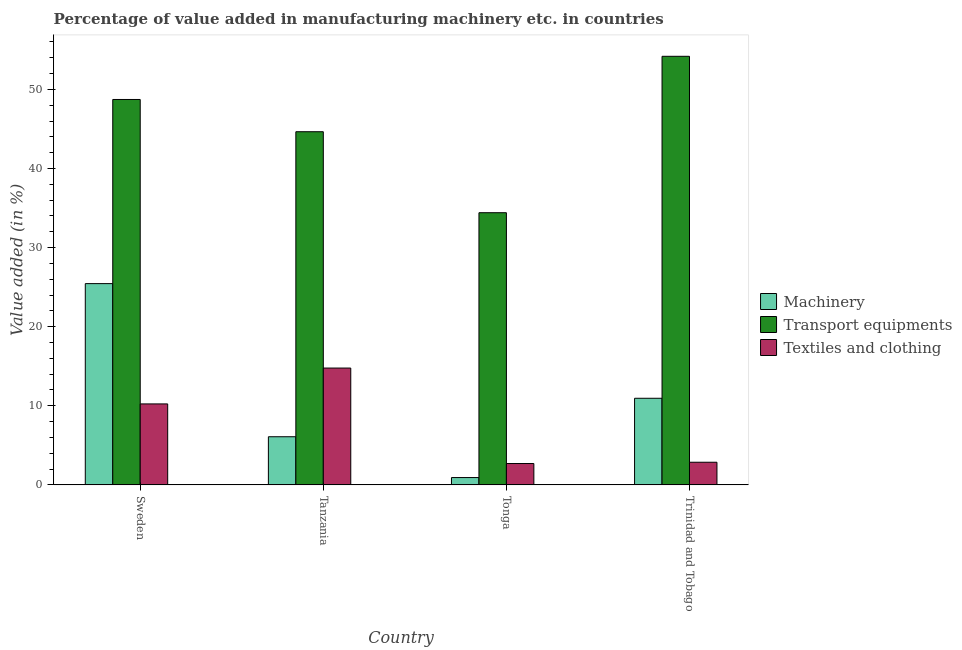How many groups of bars are there?
Keep it short and to the point. 4. Are the number of bars on each tick of the X-axis equal?
Provide a succinct answer. Yes. How many bars are there on the 1st tick from the right?
Make the answer very short. 3. What is the label of the 2nd group of bars from the left?
Ensure brevity in your answer.  Tanzania. In how many cases, is the number of bars for a given country not equal to the number of legend labels?
Keep it short and to the point. 0. What is the value added in manufacturing textile and clothing in Sweden?
Your response must be concise. 10.24. Across all countries, what is the maximum value added in manufacturing transport equipments?
Offer a terse response. 54.19. Across all countries, what is the minimum value added in manufacturing transport equipments?
Keep it short and to the point. 34.41. In which country was the value added in manufacturing transport equipments maximum?
Provide a short and direct response. Trinidad and Tobago. In which country was the value added in manufacturing textile and clothing minimum?
Ensure brevity in your answer.  Tonga. What is the total value added in manufacturing textile and clothing in the graph?
Offer a terse response. 30.58. What is the difference between the value added in manufacturing transport equipments in Sweden and that in Tanzania?
Keep it short and to the point. 4.08. What is the difference between the value added in manufacturing textile and clothing in Trinidad and Tobago and the value added in manufacturing machinery in Tanzania?
Keep it short and to the point. -3.22. What is the average value added in manufacturing transport equipments per country?
Give a very brief answer. 45.5. What is the difference between the value added in manufacturing textile and clothing and value added in manufacturing transport equipments in Trinidad and Tobago?
Offer a terse response. -51.32. In how many countries, is the value added in manufacturing machinery greater than 26 %?
Offer a very short reply. 0. What is the ratio of the value added in manufacturing textile and clothing in Sweden to that in Trinidad and Tobago?
Offer a terse response. 3.57. Is the value added in manufacturing transport equipments in Sweden less than that in Tonga?
Offer a terse response. No. What is the difference between the highest and the second highest value added in manufacturing machinery?
Give a very brief answer. 14.5. What is the difference between the highest and the lowest value added in manufacturing transport equipments?
Provide a short and direct response. 19.78. In how many countries, is the value added in manufacturing textile and clothing greater than the average value added in manufacturing textile and clothing taken over all countries?
Keep it short and to the point. 2. Is the sum of the value added in manufacturing transport equipments in Tanzania and Tonga greater than the maximum value added in manufacturing textile and clothing across all countries?
Your answer should be very brief. Yes. What does the 1st bar from the left in Tanzania represents?
Your response must be concise. Machinery. What does the 2nd bar from the right in Tanzania represents?
Ensure brevity in your answer.  Transport equipments. Are all the bars in the graph horizontal?
Your response must be concise. No. How many countries are there in the graph?
Give a very brief answer. 4. What is the difference between two consecutive major ticks on the Y-axis?
Offer a very short reply. 10. Are the values on the major ticks of Y-axis written in scientific E-notation?
Offer a very short reply. No. Does the graph contain any zero values?
Provide a short and direct response. No. Does the graph contain grids?
Your answer should be very brief. No. What is the title of the graph?
Provide a succinct answer. Percentage of value added in manufacturing machinery etc. in countries. What is the label or title of the X-axis?
Your answer should be compact. Country. What is the label or title of the Y-axis?
Your response must be concise. Value added (in %). What is the Value added (in %) of Machinery in Sweden?
Keep it short and to the point. 25.45. What is the Value added (in %) in Transport equipments in Sweden?
Offer a very short reply. 48.73. What is the Value added (in %) in Textiles and clothing in Sweden?
Ensure brevity in your answer.  10.24. What is the Value added (in %) in Machinery in Tanzania?
Your answer should be compact. 6.09. What is the Value added (in %) of Transport equipments in Tanzania?
Ensure brevity in your answer.  44.65. What is the Value added (in %) in Textiles and clothing in Tanzania?
Keep it short and to the point. 14.77. What is the Value added (in %) in Machinery in Tonga?
Keep it short and to the point. 0.93. What is the Value added (in %) in Transport equipments in Tonga?
Offer a terse response. 34.41. What is the Value added (in %) of Textiles and clothing in Tonga?
Keep it short and to the point. 2.7. What is the Value added (in %) in Machinery in Trinidad and Tobago?
Offer a very short reply. 10.95. What is the Value added (in %) of Transport equipments in Trinidad and Tobago?
Make the answer very short. 54.19. What is the Value added (in %) in Textiles and clothing in Trinidad and Tobago?
Give a very brief answer. 2.86. Across all countries, what is the maximum Value added (in %) of Machinery?
Ensure brevity in your answer.  25.45. Across all countries, what is the maximum Value added (in %) in Transport equipments?
Ensure brevity in your answer.  54.19. Across all countries, what is the maximum Value added (in %) in Textiles and clothing?
Keep it short and to the point. 14.77. Across all countries, what is the minimum Value added (in %) of Machinery?
Ensure brevity in your answer.  0.93. Across all countries, what is the minimum Value added (in %) of Transport equipments?
Provide a short and direct response. 34.41. Across all countries, what is the minimum Value added (in %) in Textiles and clothing?
Your answer should be very brief. 2.7. What is the total Value added (in %) of Machinery in the graph?
Offer a terse response. 43.42. What is the total Value added (in %) in Transport equipments in the graph?
Offer a very short reply. 181.99. What is the total Value added (in %) in Textiles and clothing in the graph?
Make the answer very short. 30.58. What is the difference between the Value added (in %) in Machinery in Sweden and that in Tanzania?
Keep it short and to the point. 19.36. What is the difference between the Value added (in %) in Transport equipments in Sweden and that in Tanzania?
Keep it short and to the point. 4.08. What is the difference between the Value added (in %) in Textiles and clothing in Sweden and that in Tanzania?
Give a very brief answer. -4.54. What is the difference between the Value added (in %) of Machinery in Sweden and that in Tonga?
Ensure brevity in your answer.  24.52. What is the difference between the Value added (in %) in Transport equipments in Sweden and that in Tonga?
Make the answer very short. 14.32. What is the difference between the Value added (in %) of Textiles and clothing in Sweden and that in Tonga?
Give a very brief answer. 7.54. What is the difference between the Value added (in %) in Machinery in Sweden and that in Trinidad and Tobago?
Keep it short and to the point. 14.5. What is the difference between the Value added (in %) of Transport equipments in Sweden and that in Trinidad and Tobago?
Make the answer very short. -5.46. What is the difference between the Value added (in %) in Textiles and clothing in Sweden and that in Trinidad and Tobago?
Give a very brief answer. 7.37. What is the difference between the Value added (in %) in Machinery in Tanzania and that in Tonga?
Keep it short and to the point. 5.16. What is the difference between the Value added (in %) of Transport equipments in Tanzania and that in Tonga?
Provide a short and direct response. 10.24. What is the difference between the Value added (in %) of Textiles and clothing in Tanzania and that in Tonga?
Make the answer very short. 12.07. What is the difference between the Value added (in %) in Machinery in Tanzania and that in Trinidad and Tobago?
Give a very brief answer. -4.86. What is the difference between the Value added (in %) of Transport equipments in Tanzania and that in Trinidad and Tobago?
Offer a terse response. -9.54. What is the difference between the Value added (in %) of Textiles and clothing in Tanzania and that in Trinidad and Tobago?
Provide a succinct answer. 11.91. What is the difference between the Value added (in %) of Machinery in Tonga and that in Trinidad and Tobago?
Provide a succinct answer. -10.02. What is the difference between the Value added (in %) in Transport equipments in Tonga and that in Trinidad and Tobago?
Provide a short and direct response. -19.78. What is the difference between the Value added (in %) in Textiles and clothing in Tonga and that in Trinidad and Tobago?
Ensure brevity in your answer.  -0.16. What is the difference between the Value added (in %) in Machinery in Sweden and the Value added (in %) in Transport equipments in Tanzania?
Give a very brief answer. -19.2. What is the difference between the Value added (in %) of Machinery in Sweden and the Value added (in %) of Textiles and clothing in Tanzania?
Your response must be concise. 10.68. What is the difference between the Value added (in %) in Transport equipments in Sweden and the Value added (in %) in Textiles and clothing in Tanzania?
Keep it short and to the point. 33.96. What is the difference between the Value added (in %) of Machinery in Sweden and the Value added (in %) of Transport equipments in Tonga?
Provide a short and direct response. -8.96. What is the difference between the Value added (in %) in Machinery in Sweden and the Value added (in %) in Textiles and clothing in Tonga?
Your response must be concise. 22.75. What is the difference between the Value added (in %) in Transport equipments in Sweden and the Value added (in %) in Textiles and clothing in Tonga?
Ensure brevity in your answer.  46.03. What is the difference between the Value added (in %) of Machinery in Sweden and the Value added (in %) of Transport equipments in Trinidad and Tobago?
Offer a very short reply. -28.74. What is the difference between the Value added (in %) of Machinery in Sweden and the Value added (in %) of Textiles and clothing in Trinidad and Tobago?
Provide a succinct answer. 22.58. What is the difference between the Value added (in %) of Transport equipments in Sweden and the Value added (in %) of Textiles and clothing in Trinidad and Tobago?
Offer a terse response. 45.87. What is the difference between the Value added (in %) of Machinery in Tanzania and the Value added (in %) of Transport equipments in Tonga?
Your answer should be very brief. -28.33. What is the difference between the Value added (in %) of Machinery in Tanzania and the Value added (in %) of Textiles and clothing in Tonga?
Your answer should be compact. 3.39. What is the difference between the Value added (in %) in Transport equipments in Tanzania and the Value added (in %) in Textiles and clothing in Tonga?
Ensure brevity in your answer.  41.95. What is the difference between the Value added (in %) in Machinery in Tanzania and the Value added (in %) in Transport equipments in Trinidad and Tobago?
Your answer should be compact. -48.1. What is the difference between the Value added (in %) in Machinery in Tanzania and the Value added (in %) in Textiles and clothing in Trinidad and Tobago?
Give a very brief answer. 3.22. What is the difference between the Value added (in %) in Transport equipments in Tanzania and the Value added (in %) in Textiles and clothing in Trinidad and Tobago?
Offer a very short reply. 41.79. What is the difference between the Value added (in %) of Machinery in Tonga and the Value added (in %) of Transport equipments in Trinidad and Tobago?
Provide a short and direct response. -53.26. What is the difference between the Value added (in %) in Machinery in Tonga and the Value added (in %) in Textiles and clothing in Trinidad and Tobago?
Provide a short and direct response. -1.94. What is the difference between the Value added (in %) in Transport equipments in Tonga and the Value added (in %) in Textiles and clothing in Trinidad and Tobago?
Provide a succinct answer. 31.55. What is the average Value added (in %) of Machinery per country?
Give a very brief answer. 10.85. What is the average Value added (in %) in Transport equipments per country?
Make the answer very short. 45.5. What is the average Value added (in %) in Textiles and clothing per country?
Ensure brevity in your answer.  7.64. What is the difference between the Value added (in %) of Machinery and Value added (in %) of Transport equipments in Sweden?
Offer a very short reply. -23.28. What is the difference between the Value added (in %) in Machinery and Value added (in %) in Textiles and clothing in Sweden?
Offer a very short reply. 15.21. What is the difference between the Value added (in %) in Transport equipments and Value added (in %) in Textiles and clothing in Sweden?
Your answer should be compact. 38.49. What is the difference between the Value added (in %) in Machinery and Value added (in %) in Transport equipments in Tanzania?
Offer a terse response. -38.57. What is the difference between the Value added (in %) of Machinery and Value added (in %) of Textiles and clothing in Tanzania?
Provide a succinct answer. -8.69. What is the difference between the Value added (in %) of Transport equipments and Value added (in %) of Textiles and clothing in Tanzania?
Ensure brevity in your answer.  29.88. What is the difference between the Value added (in %) in Machinery and Value added (in %) in Transport equipments in Tonga?
Provide a short and direct response. -33.48. What is the difference between the Value added (in %) in Machinery and Value added (in %) in Textiles and clothing in Tonga?
Your response must be concise. -1.77. What is the difference between the Value added (in %) in Transport equipments and Value added (in %) in Textiles and clothing in Tonga?
Make the answer very short. 31.71. What is the difference between the Value added (in %) in Machinery and Value added (in %) in Transport equipments in Trinidad and Tobago?
Provide a short and direct response. -43.24. What is the difference between the Value added (in %) of Machinery and Value added (in %) of Textiles and clothing in Trinidad and Tobago?
Provide a succinct answer. 8.09. What is the difference between the Value added (in %) of Transport equipments and Value added (in %) of Textiles and clothing in Trinidad and Tobago?
Your answer should be compact. 51.32. What is the ratio of the Value added (in %) in Machinery in Sweden to that in Tanzania?
Give a very brief answer. 4.18. What is the ratio of the Value added (in %) in Transport equipments in Sweden to that in Tanzania?
Your answer should be compact. 1.09. What is the ratio of the Value added (in %) of Textiles and clothing in Sweden to that in Tanzania?
Make the answer very short. 0.69. What is the ratio of the Value added (in %) in Machinery in Sweden to that in Tonga?
Give a very brief answer. 27.41. What is the ratio of the Value added (in %) of Transport equipments in Sweden to that in Tonga?
Make the answer very short. 1.42. What is the ratio of the Value added (in %) of Textiles and clothing in Sweden to that in Tonga?
Your response must be concise. 3.79. What is the ratio of the Value added (in %) in Machinery in Sweden to that in Trinidad and Tobago?
Make the answer very short. 2.32. What is the ratio of the Value added (in %) in Transport equipments in Sweden to that in Trinidad and Tobago?
Your response must be concise. 0.9. What is the ratio of the Value added (in %) of Textiles and clothing in Sweden to that in Trinidad and Tobago?
Keep it short and to the point. 3.57. What is the ratio of the Value added (in %) of Machinery in Tanzania to that in Tonga?
Keep it short and to the point. 6.56. What is the ratio of the Value added (in %) in Transport equipments in Tanzania to that in Tonga?
Provide a succinct answer. 1.3. What is the ratio of the Value added (in %) in Textiles and clothing in Tanzania to that in Tonga?
Provide a succinct answer. 5.47. What is the ratio of the Value added (in %) in Machinery in Tanzania to that in Trinidad and Tobago?
Give a very brief answer. 0.56. What is the ratio of the Value added (in %) of Transport equipments in Tanzania to that in Trinidad and Tobago?
Provide a short and direct response. 0.82. What is the ratio of the Value added (in %) in Textiles and clothing in Tanzania to that in Trinidad and Tobago?
Keep it short and to the point. 5.16. What is the ratio of the Value added (in %) in Machinery in Tonga to that in Trinidad and Tobago?
Make the answer very short. 0.08. What is the ratio of the Value added (in %) in Transport equipments in Tonga to that in Trinidad and Tobago?
Give a very brief answer. 0.64. What is the ratio of the Value added (in %) in Textiles and clothing in Tonga to that in Trinidad and Tobago?
Keep it short and to the point. 0.94. What is the difference between the highest and the second highest Value added (in %) of Machinery?
Make the answer very short. 14.5. What is the difference between the highest and the second highest Value added (in %) of Transport equipments?
Your answer should be very brief. 5.46. What is the difference between the highest and the second highest Value added (in %) of Textiles and clothing?
Provide a succinct answer. 4.54. What is the difference between the highest and the lowest Value added (in %) of Machinery?
Your answer should be compact. 24.52. What is the difference between the highest and the lowest Value added (in %) in Transport equipments?
Offer a very short reply. 19.78. What is the difference between the highest and the lowest Value added (in %) of Textiles and clothing?
Offer a very short reply. 12.07. 